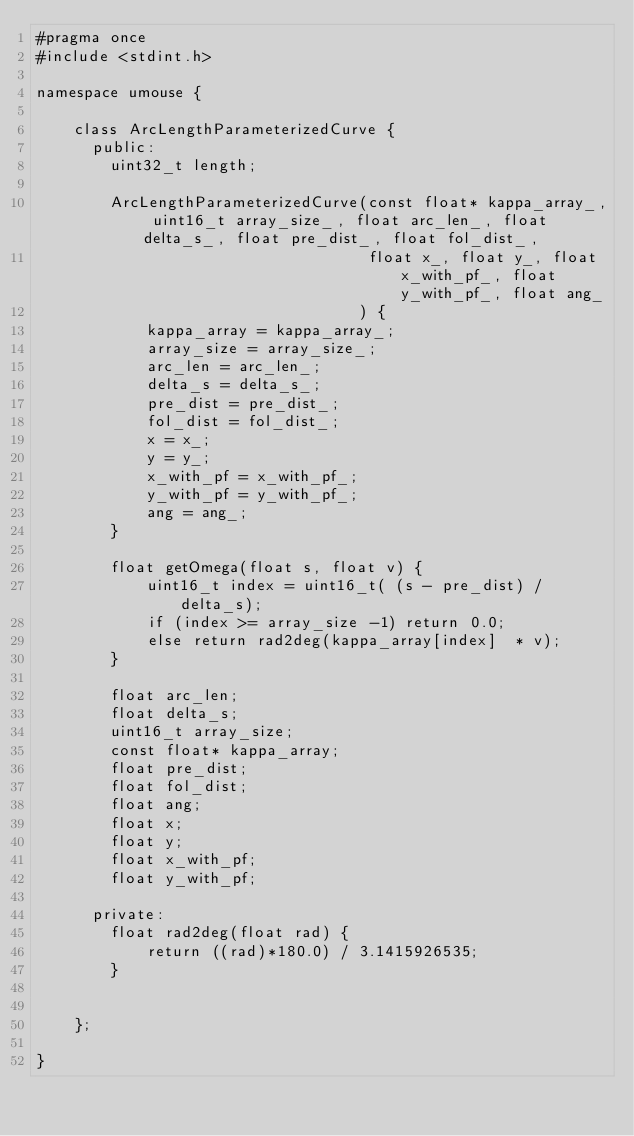Convert code to text. <code><loc_0><loc_0><loc_500><loc_500><_C_>#pragma once
#include <stdint.h>

namespace umouse {

    class ArcLengthParameterizedCurve {
      public:
        uint32_t length;

        ArcLengthParameterizedCurve(const float* kappa_array_, uint16_t array_size_, float arc_len_, float delta_s_, float pre_dist_, float fol_dist_,
                                    float x_, float y_, float x_with_pf_, float y_with_pf_, float ang_
                                   ) {
            kappa_array = kappa_array_;
            array_size = array_size_;
            arc_len = arc_len_;
            delta_s = delta_s_;
            pre_dist = pre_dist_;
            fol_dist = fol_dist_;
            x = x_;
            y = y_;
            x_with_pf = x_with_pf_;
            y_with_pf = y_with_pf_;
            ang = ang_;
        }

        float getOmega(float s, float v) {
            uint16_t index = uint16_t( (s - pre_dist) / delta_s);
            if (index >= array_size -1) return 0.0;
            else return rad2deg(kappa_array[index]  * v);
        }

        float arc_len;
        float delta_s;
        uint16_t array_size;
        const float* kappa_array;
        float pre_dist;
        float fol_dist;
        float ang;
        float x;
        float y;
        float x_with_pf;
        float y_with_pf;

      private:
        float rad2deg(float rad) {
            return ((rad)*180.0) / 3.1415926535;
        }


    };

}

</code> 